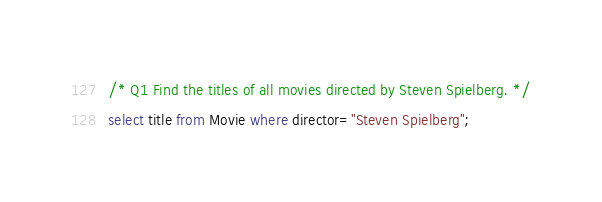Convert code to text. <code><loc_0><loc_0><loc_500><loc_500><_SQL_>/* Q1 Find the titles of all movies directed by Steven Spielberg. */
select title from Movie where director="Steven Spielberg";
</code> 